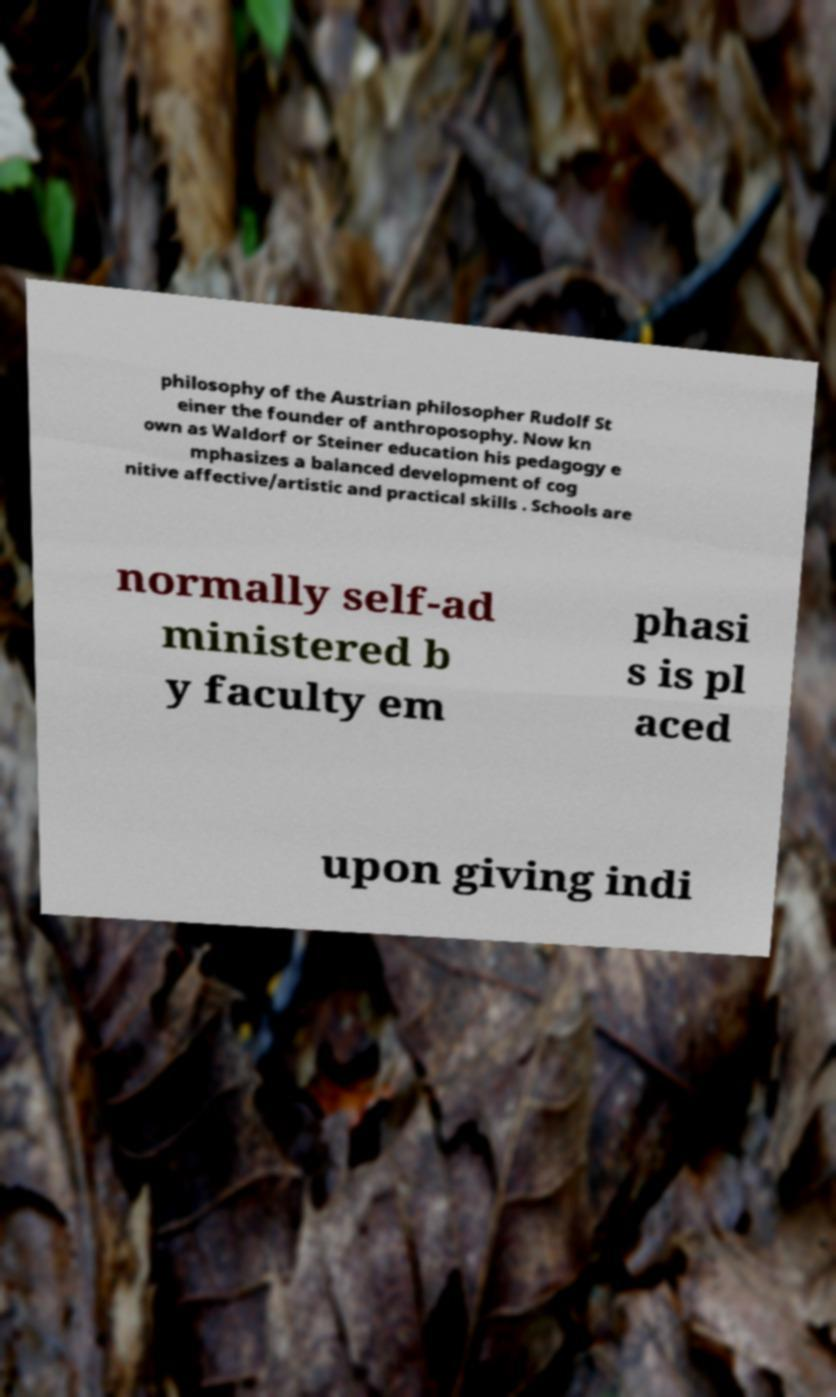There's text embedded in this image that I need extracted. Can you transcribe it verbatim? philosophy of the Austrian philosopher Rudolf St einer the founder of anthroposophy. Now kn own as Waldorf or Steiner education his pedagogy e mphasizes a balanced development of cog nitive affective/artistic and practical skills . Schools are normally self-ad ministered b y faculty em phasi s is pl aced upon giving indi 